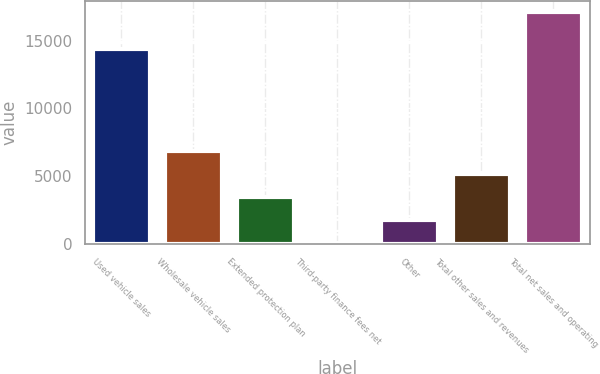<chart> <loc_0><loc_0><loc_500><loc_500><bar_chart><fcel>Used vehicle sales<fcel>Wholesale vehicle sales<fcel>Extended protection plan<fcel>Third-party finance fees net<fcel>Other<fcel>Total other sales and revenues<fcel>Total net sales and operating<nl><fcel>14392.4<fcel>6878.02<fcel>3463.96<fcel>49.9<fcel>1756.93<fcel>5170.99<fcel>17120.2<nl></chart> 